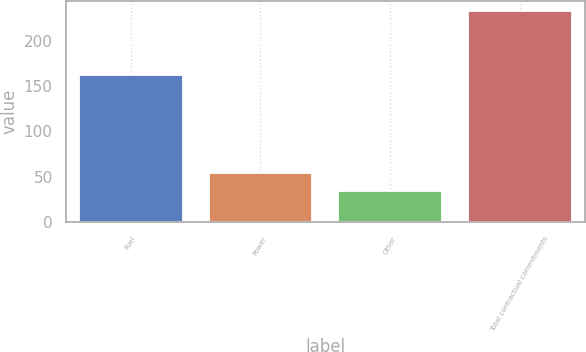Convert chart to OTSL. <chart><loc_0><loc_0><loc_500><loc_500><bar_chart><fcel>Fuel<fcel>Power<fcel>Other<fcel>Total contractual commitments<nl><fcel>162.6<fcel>54.44<fcel>34.7<fcel>232.1<nl></chart> 